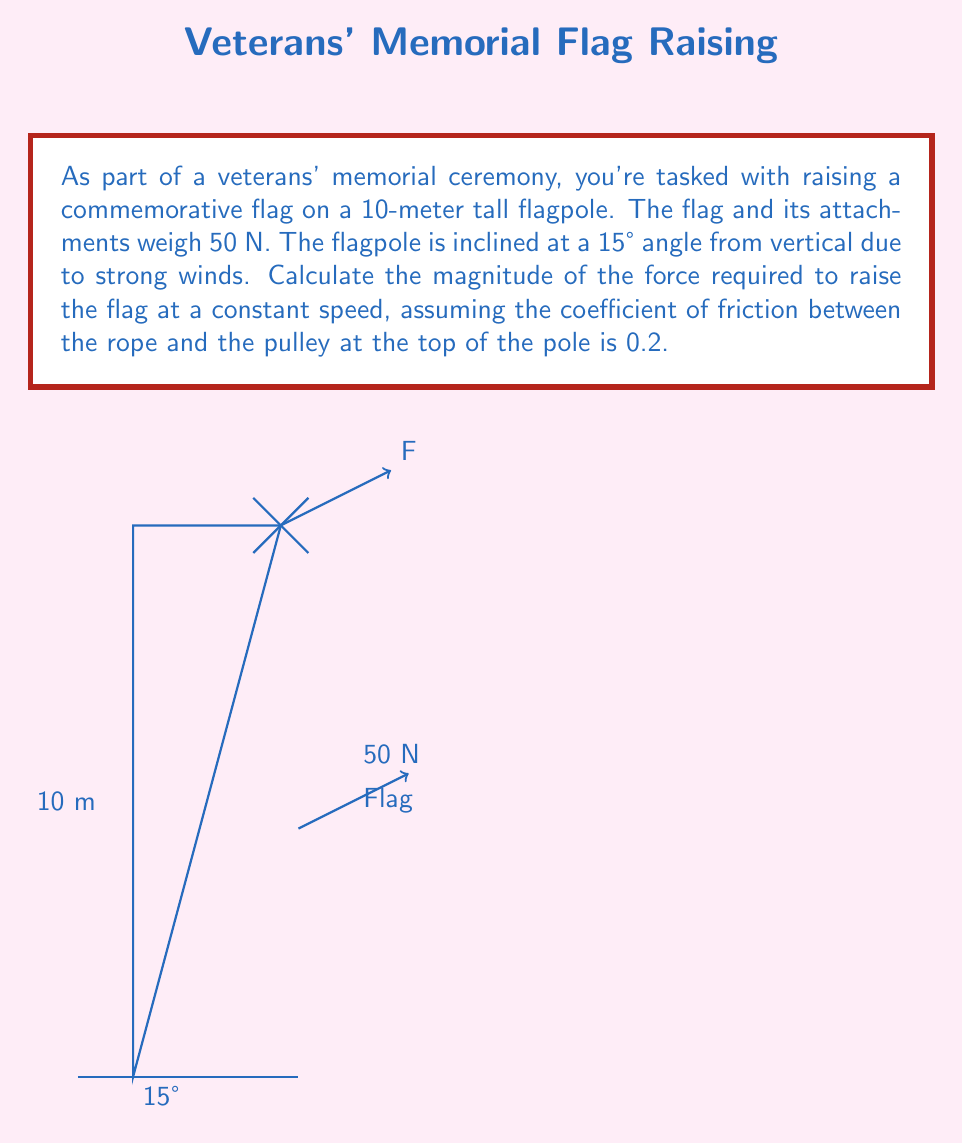Could you help me with this problem? Let's approach this problem step-by-step:

1) First, we need to resolve the weight of the flag (50 N) into components parallel and perpendicular to the flagpole:

   Parallel component: $F_{\parallel} = 50 \sin 15° = 50 \cdot 0.2588 = 12.94$ N
   Perpendicular component: $F_{\perp} = 50 \cos 15° = 50 \cdot 0.9659 = 48.30$ N

2) The force of friction is given by $\mu N$, where $\mu$ is the coefficient of friction and $N$ is the normal force. The normal force is equal to the perpendicular component of the weight:

   $F_f = 0.2 \cdot 48.30 = 9.66$ N

3) To raise the flag at constant speed, the applied force must overcome both the parallel component of the weight and the friction force:

   $F = F_{\parallel} + F_f = 12.94 + 9.66 = 22.60$ N

4) However, this force is parallel to the flagpole. We need to find the vertical component of this force:

   $F_{vertical} = \frac{F}{\cos 15°} = \frac{22.60}{0.9659} = 23.40$ N

Therefore, the magnitude of the force required to raise the flag at a constant speed is approximately 23.40 N.
Answer: $23.40$ N 